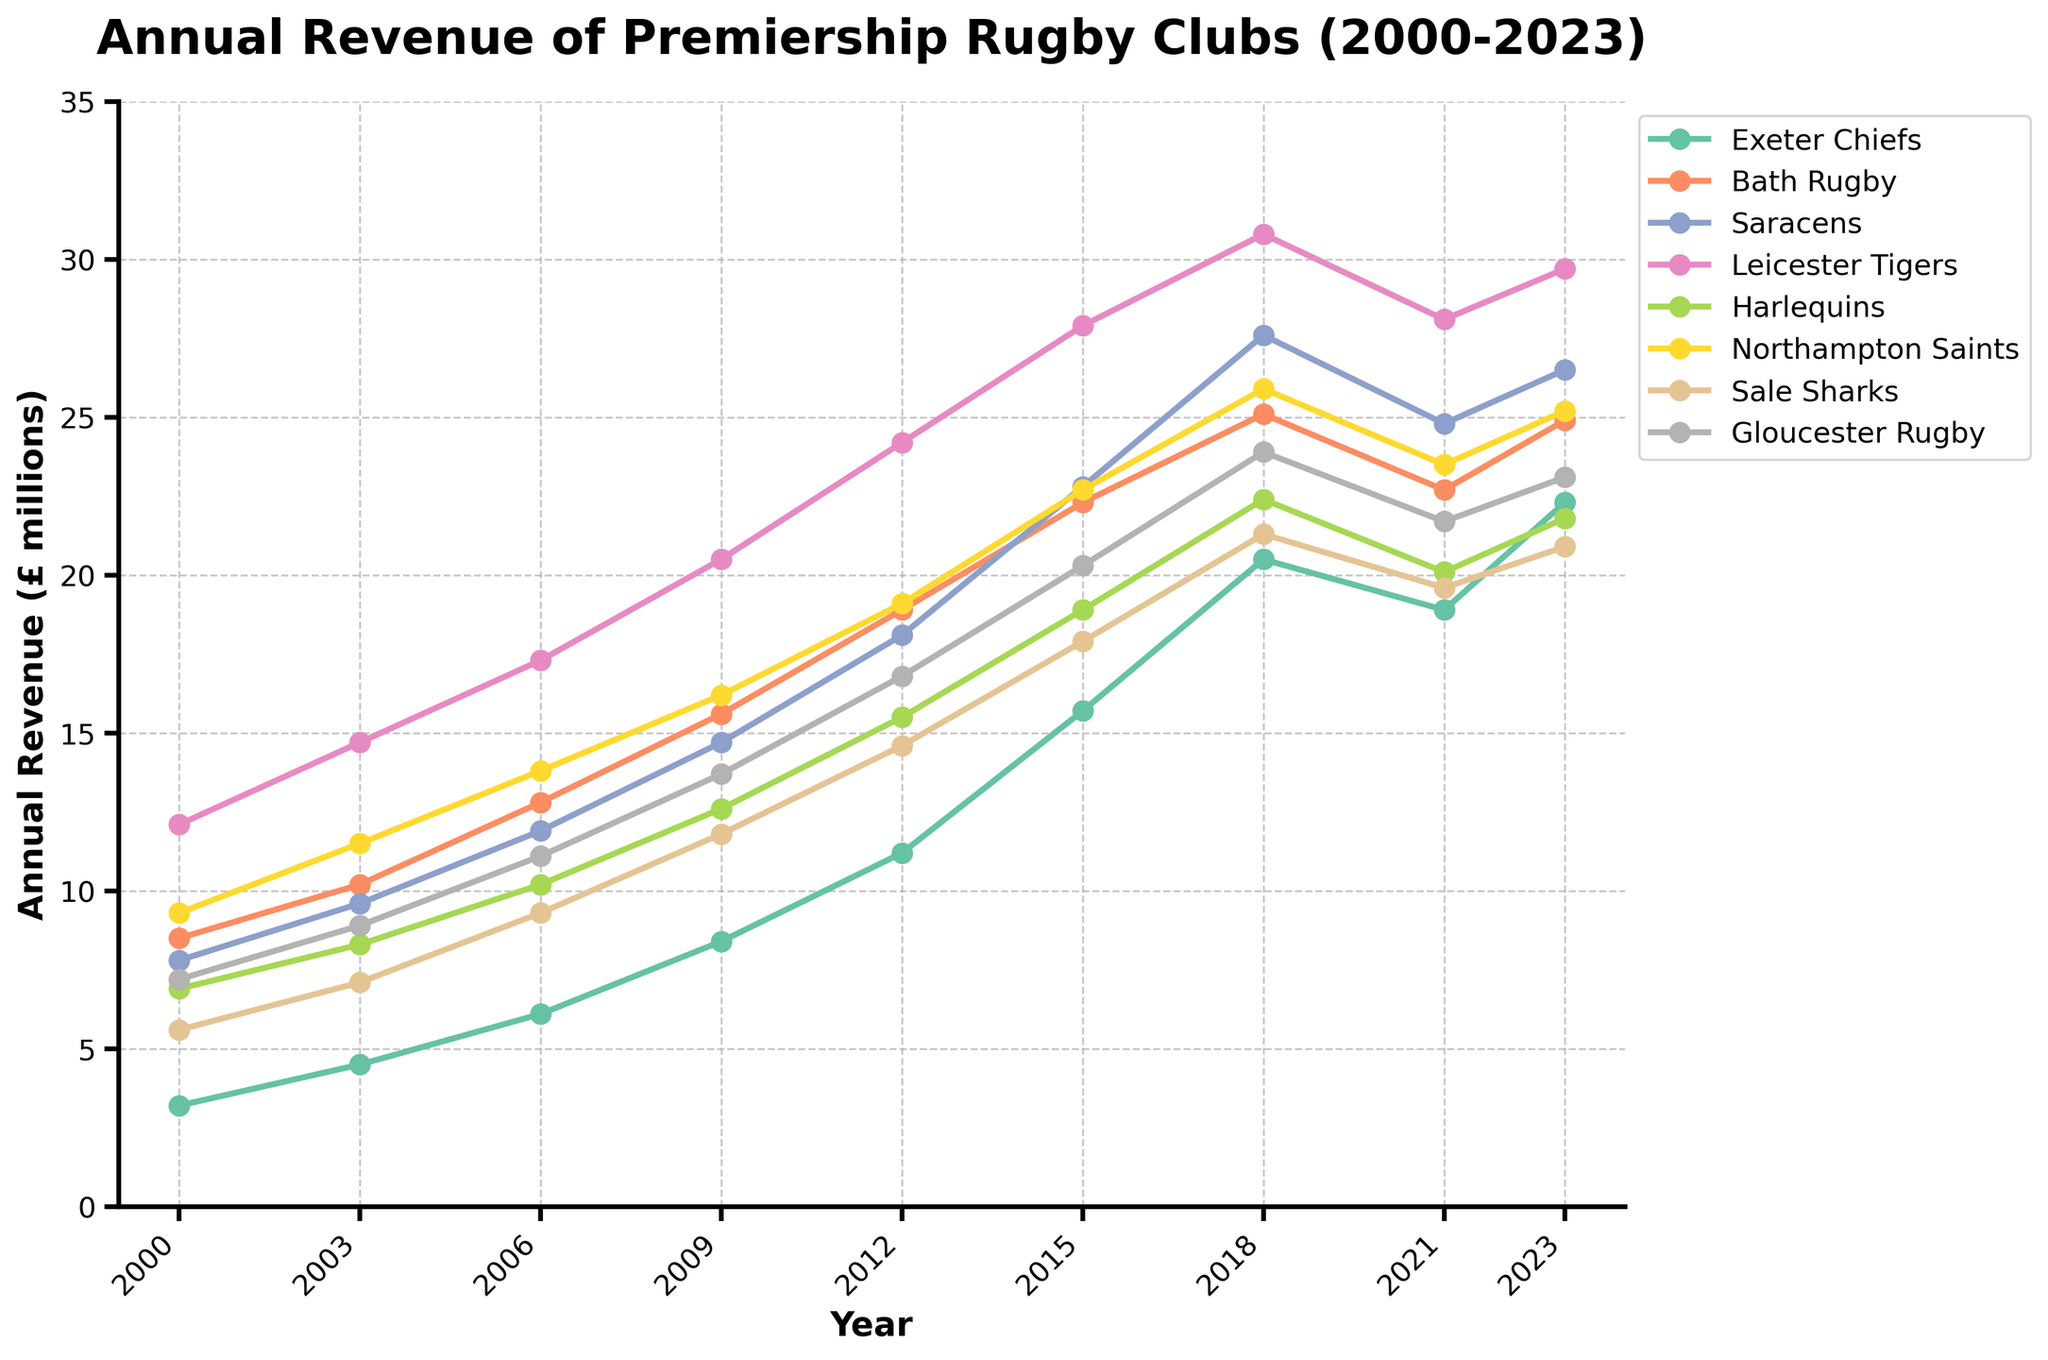What was the approximate revenue of the Exeter Chiefs in 2023? By looking at the plotted values for Exeter Chiefs in the year 2023, we can observe the y-coordinate point and determine the revenue.
Answer: £22.3 million Which club had the highest annual revenue in 2000? For the year 2000, we compare the y-values of all clubs and see which one is the highest. The Leicester Tigers had the highest revenue as their point is the highest.
Answer: Leicester Tigers How did the revenue for Bath Rugby change from 2000 to 2023? We compare the revenue values for Bath Rugby in the years 2000 and 2023. In 2000, the revenue was £8.5 million, and in 2023, it was £24.9 million. Thus, the change is £24.9 million - £8.5 million.
Answer: Increased by £16.4 million Which club had the smallest increase in revenue from 2018 to 2023? We compare the difference in revenue values for all clubs between 2018 and 2023. Sale Sharks had an increase from £21.3 million to £22.3 million which is £1 million.
Answer: Sale Sharks Which clubs had their peak revenue in 2018? By visually inspecting the plot, we find the highest points for each club. Saracens, Leicester Tigers, and Gloucester Rugby all had their peak revenues in 2018.
Answer: Saracens, Leicester Tigers, Gloucester Rugby Between 2015 and 2021, which club experienced a decline in revenue? Comparing the y-values for each club between 2015 and 2021, we see that Exeter Chiefs and Bath Rugby had revenue decreases.
Answer: Exeter Chiefs, Bath Rugby What is the average revenue of the Exeter Chiefs over all years? Summing up annual revenues for the Exeter Chiefs and dividing by the number of years: (3.2 + 4.5 + 6.1 + 8.4 + 11.2 + 15.7 + 20.5 + 18.9 + 22.3) / 9
Answer: £12.3 million In which year did all clubs experience a noticeable increase in revenue compared to the previous period? Observing the trends and comparing consecutive years, between 2009 and 2012, all clubs had a noticeable increase in their revenues.
Answer: 2012 Which club had the most consistent revenue growth over the period? By examining all trend lines, we see that the line for Leicester Tigers shows a relatively steady and consistent increase without major fluctuations.
Answer: Leicester Tigers 